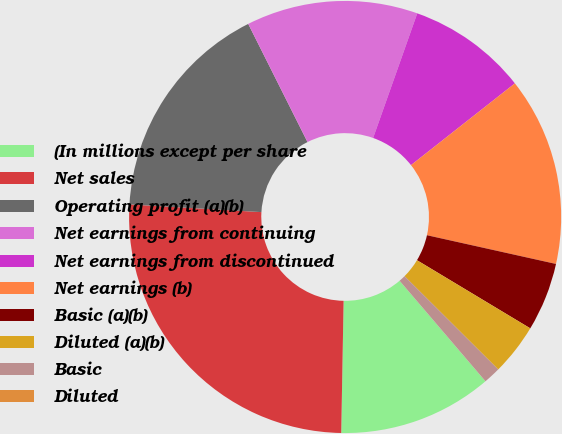<chart> <loc_0><loc_0><loc_500><loc_500><pie_chart><fcel>(In millions except per share<fcel>Net sales<fcel>Operating profit (a)(b)<fcel>Net earnings from continuing<fcel>Net earnings from discontinued<fcel>Net earnings (b)<fcel>Basic (a)(b)<fcel>Diluted (a)(b)<fcel>Basic<fcel>Diluted<nl><fcel>11.54%<fcel>25.64%<fcel>16.67%<fcel>12.82%<fcel>8.97%<fcel>14.1%<fcel>5.13%<fcel>3.85%<fcel>1.28%<fcel>0.0%<nl></chart> 